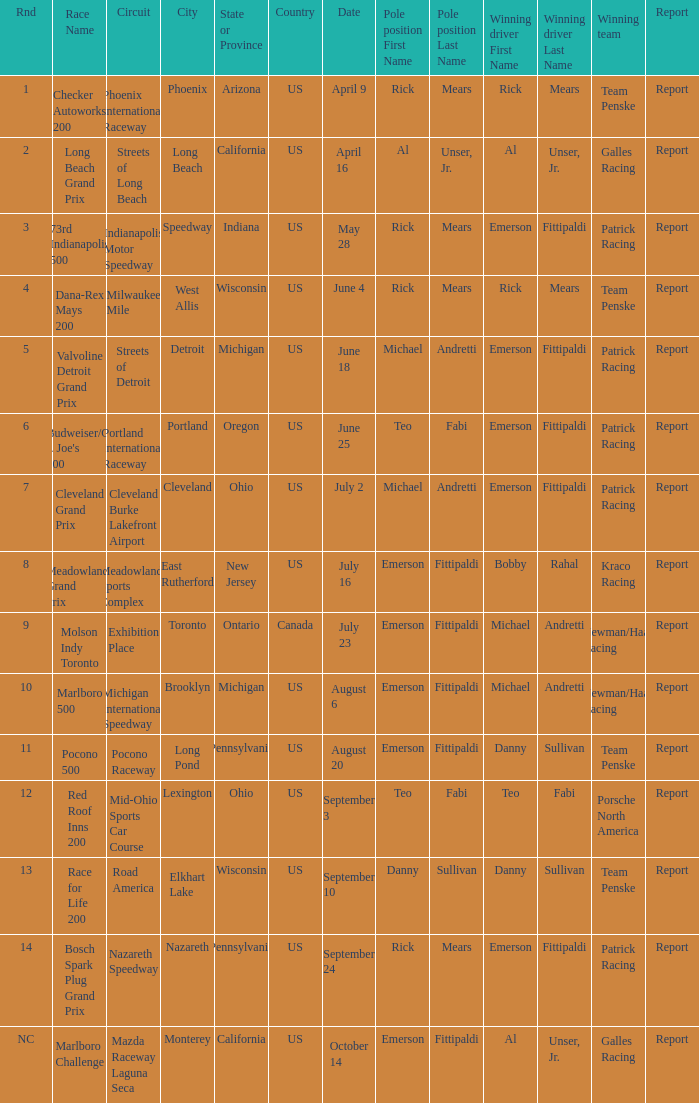How many winning drivers were the for the rnd equalling 5? 1.0. 